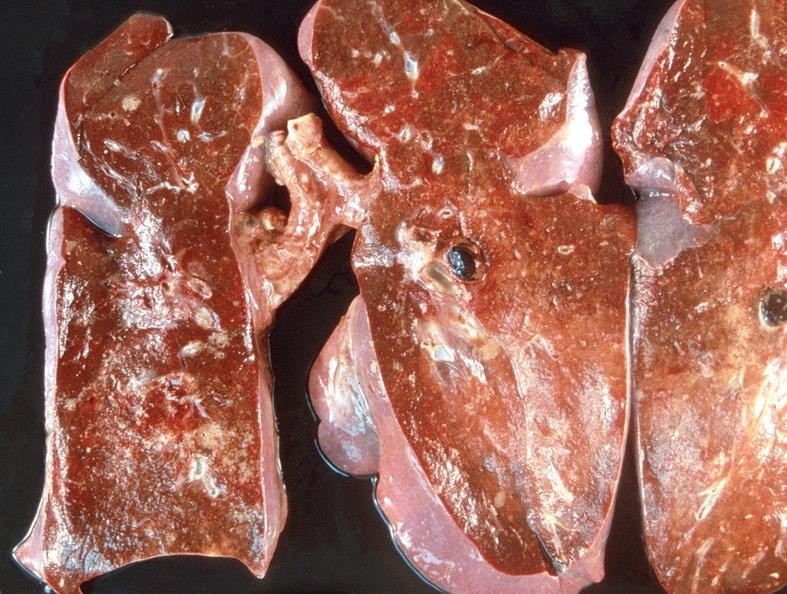where is this?
Answer the question using a single word or phrase. Lung 